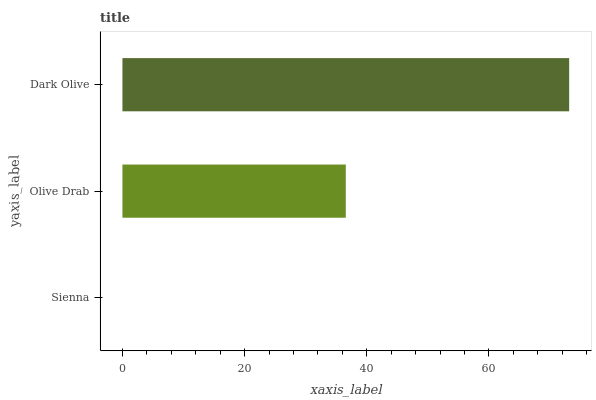Is Sienna the minimum?
Answer yes or no. Yes. Is Dark Olive the maximum?
Answer yes or no. Yes. Is Olive Drab the minimum?
Answer yes or no. No. Is Olive Drab the maximum?
Answer yes or no. No. Is Olive Drab greater than Sienna?
Answer yes or no. Yes. Is Sienna less than Olive Drab?
Answer yes or no. Yes. Is Sienna greater than Olive Drab?
Answer yes or no. No. Is Olive Drab less than Sienna?
Answer yes or no. No. Is Olive Drab the high median?
Answer yes or no. Yes. Is Olive Drab the low median?
Answer yes or no. Yes. Is Sienna the high median?
Answer yes or no. No. Is Dark Olive the low median?
Answer yes or no. No. 